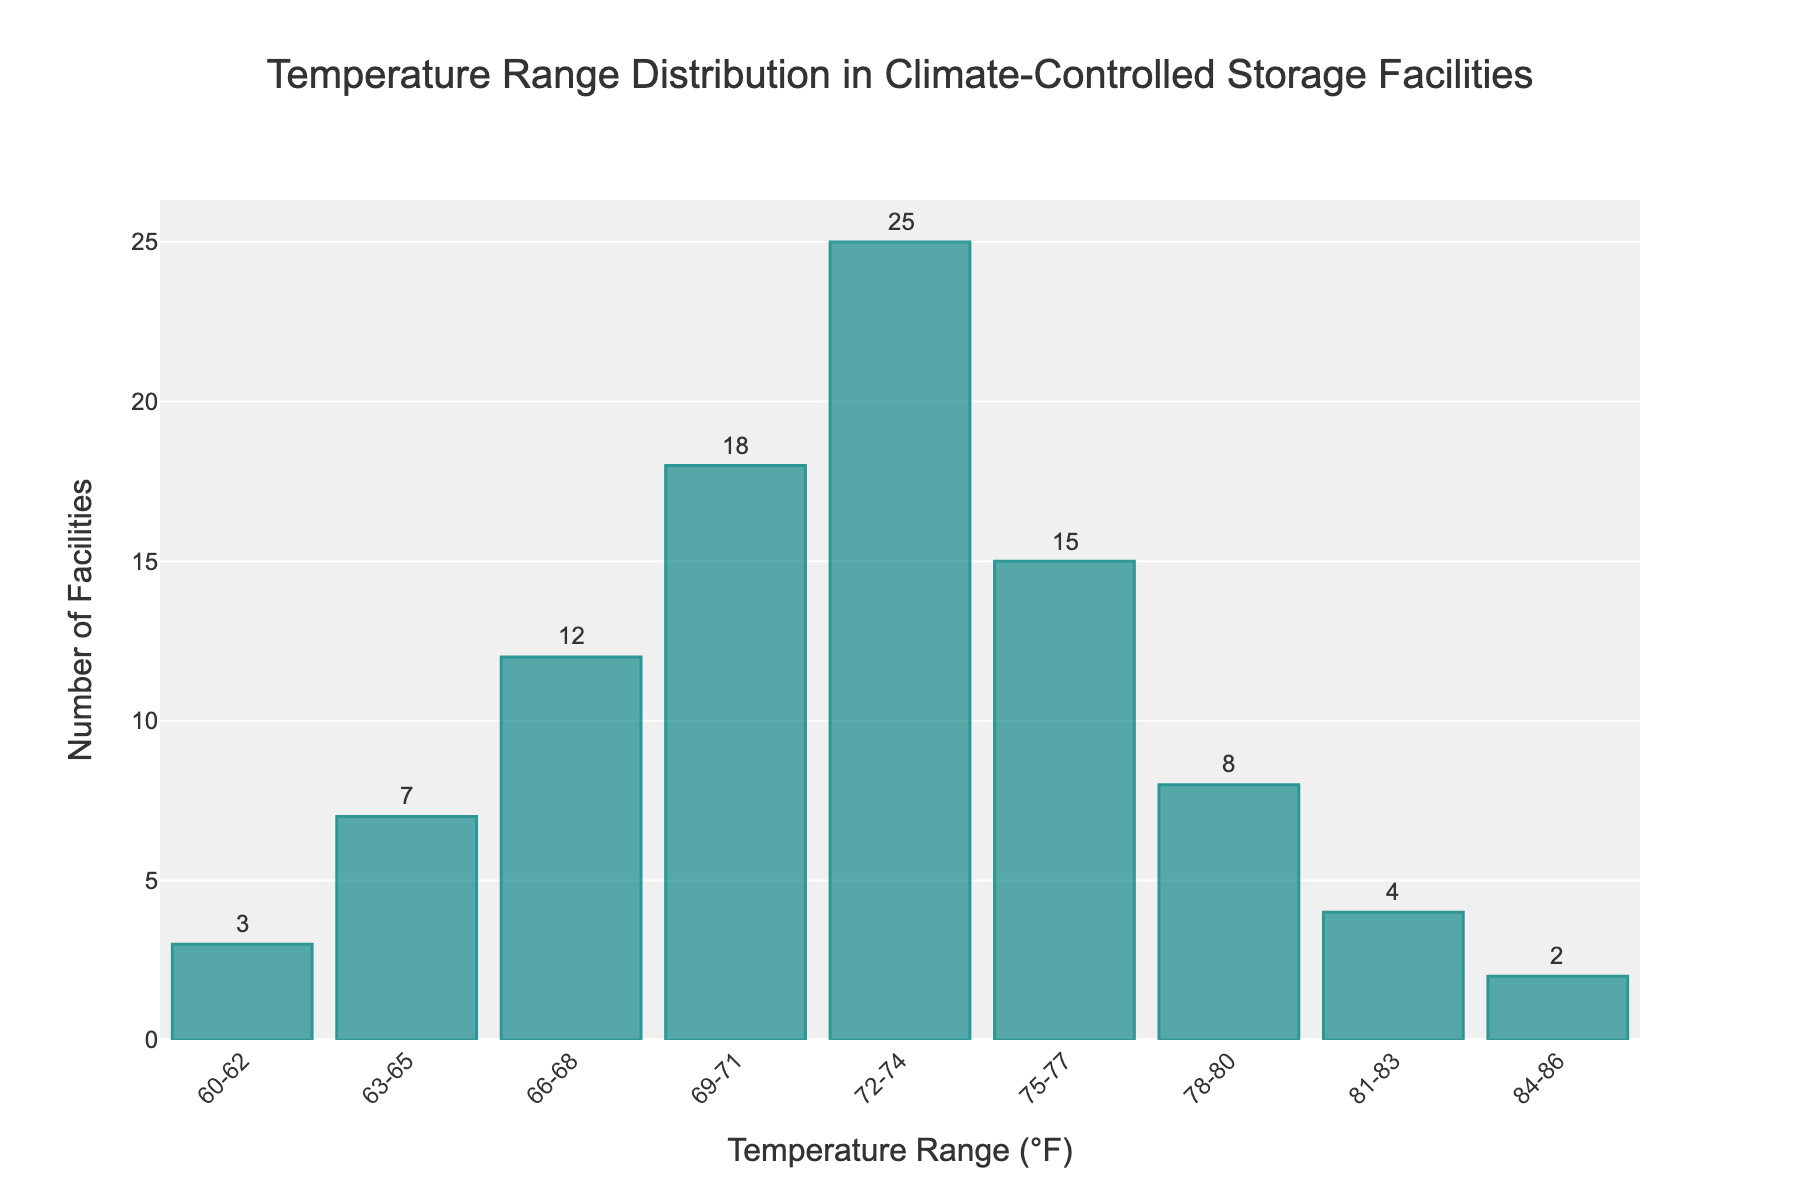Which temperature range has the highest number of facilities? Look at the y-axis values for each temperature range and identify the highest value. The highest bar represents the highest number of facilities.
Answer: 72-74 What is the total number of facilities represented in the histogram? Sum the values of all the bars. Add the number of facilities for each temperature range (3 + 7 + 12 + 18 + 25 + 15 + 8 + 4 + 2).
Answer: 94 How many facilities are within the temperature range of 75-77°F? Identify the bar corresponding to the 75-77°F range and read the y-axis value for that bar.
Answer: 15 Which temperature range(s) have fewer than 5 facilities? Check which bars have a y-axis value less than 5.
Answer: 60-62, 81-83, 84-86 What's the difference in the number of facilities between the temperature ranges 72-74°F and 78-80°F? Find the bar heights (number of facilities) for both ranges and subtract the smaller from the larger (25 - 8).
Answer: 17 What's the average number of facilities in the temperature ranges from 66-80°F? Identify the number of facilities for the ranges from 66-68°F to 78-80°F, sum these values, and divide by the number of ranges (12 + 18 + 25 + 15 + 8)/5.
Answer: 15.6 What is the most common temperature range for the storage facilities? Identify the temperature range corresponding to the tallest bar on the histogram.
Answer: 72-74 Are there more facilities in temperature ranges 69-71°F to 75-77°F compared to those in 60-62°F to 66-68°F? Sum the facilities in both groups: (18 + 25 + 15) > (3 + 7 + 12) and compare the totals (58 > 22).
Answer: Yes What is the minimum number of facilities in a temperature range on the histogram? Identify the smallest y-axis value among all bars representing the temperature ranges.
Answer: 2 How do the facilities' numbers between temperature ranges 60-62°F and 84-86°F compare? Compare the heights of the bars for 60-62°F and 84-86°F. Both bars have the same height with a value of 2.
Answer: Equal 